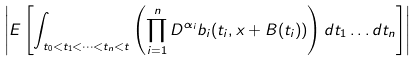<formula> <loc_0><loc_0><loc_500><loc_500>\left | E \left [ \int _ { t _ { 0 } < t _ { 1 } < \dots < t _ { n } < t } \left ( \prod _ { i = 1 } ^ { n } D ^ { \alpha _ { i } } b _ { i } ( t _ { i } , x + B ( t _ { i } ) ) \right ) d t _ { 1 } \dots d t _ { n } \right ] \right |</formula> 